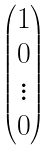<formula> <loc_0><loc_0><loc_500><loc_500>\begin{pmatrix} 1 \\ 0 \\ \vdots \\ 0 \end{pmatrix}</formula> 